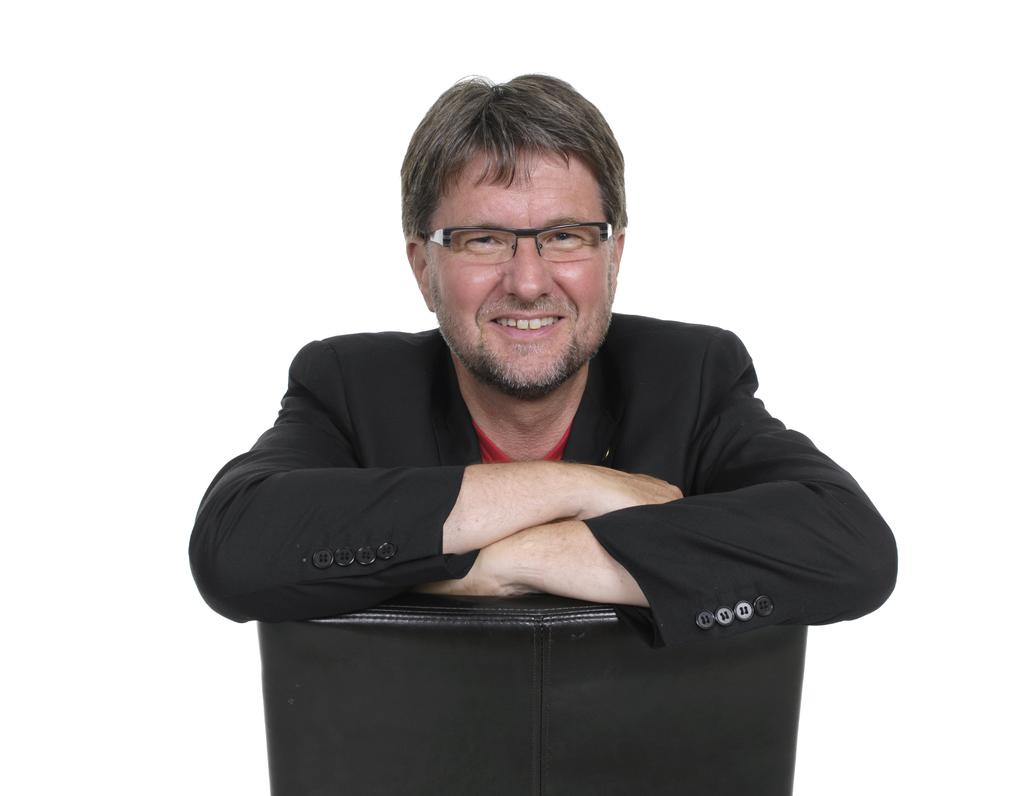What is the main subject of the image? The main subject of the image is a man. What is the man doing in the image? The man is sitting in the image. What is the man's facial expression in the image? The man is smiling in the image. What color is the coat the man is wearing? The man is wearing a black color coat. What is the man's annual income in the image? There is no information about the man's income in the image. What division does the man work for in the image? There is no information about the man's work or division in the image. 